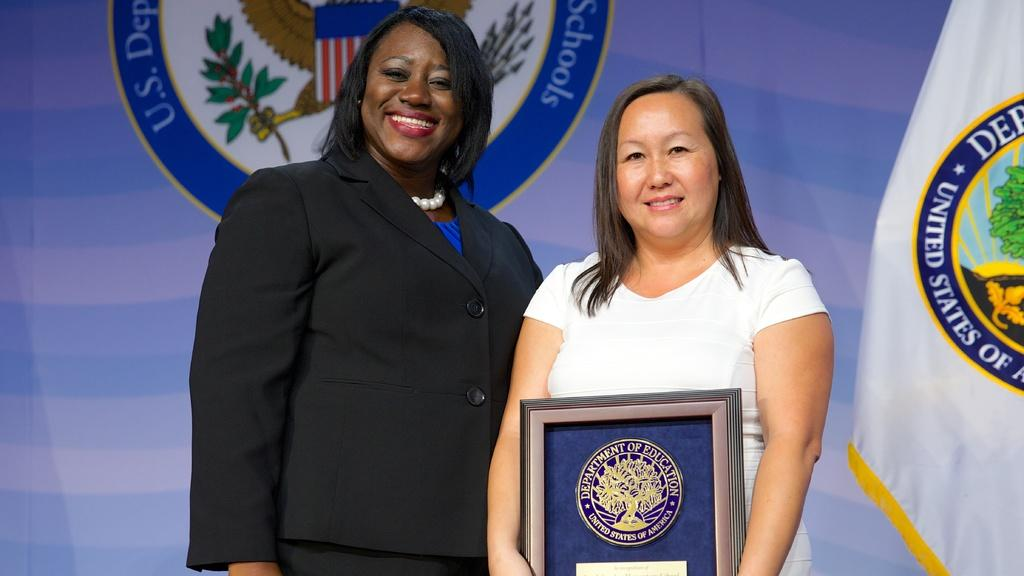<image>
Offer a succinct explanation of the picture presented. a woman with a Department of Eduction plaque 